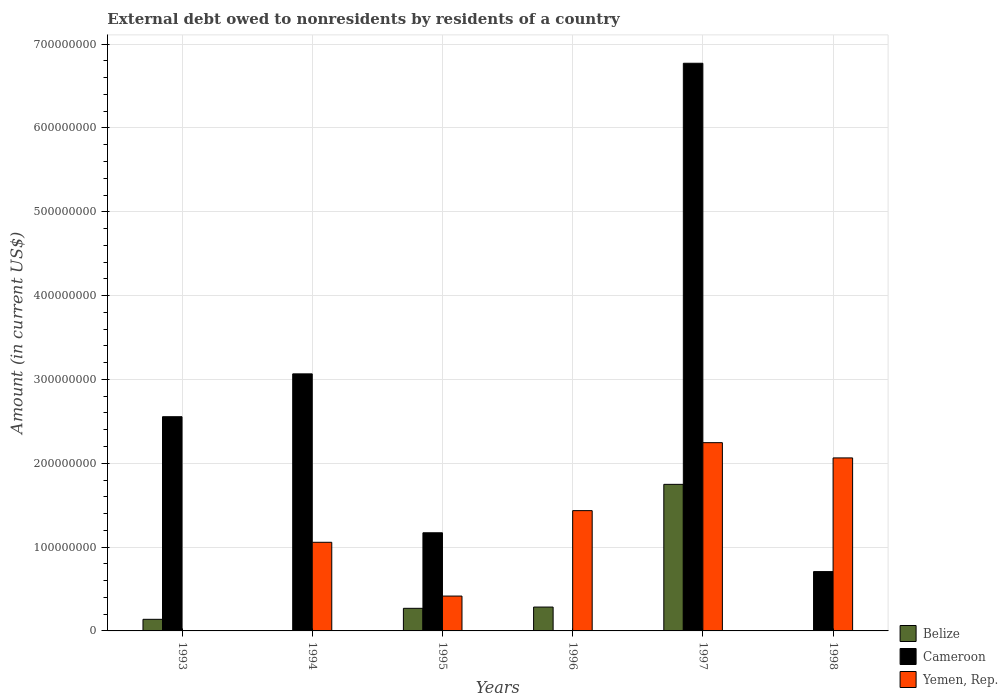How many different coloured bars are there?
Provide a short and direct response. 3. Are the number of bars on each tick of the X-axis equal?
Ensure brevity in your answer.  No. How many bars are there on the 4th tick from the right?
Ensure brevity in your answer.  3. In how many cases, is the number of bars for a given year not equal to the number of legend labels?
Provide a succinct answer. 4. What is the external debt owed by residents in Yemen, Rep. in 1997?
Make the answer very short. 2.25e+08. Across all years, what is the maximum external debt owed by residents in Yemen, Rep.?
Your response must be concise. 2.25e+08. In which year was the external debt owed by residents in Belize maximum?
Ensure brevity in your answer.  1997. What is the total external debt owed by residents in Yemen, Rep. in the graph?
Give a very brief answer. 7.22e+08. What is the difference between the external debt owed by residents in Cameroon in 1994 and that in 1998?
Provide a succinct answer. 2.36e+08. What is the difference between the external debt owed by residents in Belize in 1996 and the external debt owed by residents in Yemen, Rep. in 1994?
Your response must be concise. -7.73e+07. What is the average external debt owed by residents in Belize per year?
Keep it short and to the point. 4.07e+07. In the year 1995, what is the difference between the external debt owed by residents in Yemen, Rep. and external debt owed by residents in Cameroon?
Ensure brevity in your answer.  -7.55e+07. Is the external debt owed by residents in Belize in 1993 less than that in 1996?
Keep it short and to the point. Yes. Is the difference between the external debt owed by residents in Yemen, Rep. in 1994 and 1997 greater than the difference between the external debt owed by residents in Cameroon in 1994 and 1997?
Make the answer very short. Yes. What is the difference between the highest and the second highest external debt owed by residents in Yemen, Rep.?
Give a very brief answer. 1.82e+07. What is the difference between the highest and the lowest external debt owed by residents in Belize?
Provide a succinct answer. 1.75e+08. In how many years, is the external debt owed by residents in Yemen, Rep. greater than the average external debt owed by residents in Yemen, Rep. taken over all years?
Ensure brevity in your answer.  3. Is the sum of the external debt owed by residents in Cameroon in 1994 and 1998 greater than the maximum external debt owed by residents in Belize across all years?
Your response must be concise. Yes. Is it the case that in every year, the sum of the external debt owed by residents in Cameroon and external debt owed by residents in Belize is greater than the external debt owed by residents in Yemen, Rep.?
Provide a succinct answer. No. How many bars are there?
Provide a succinct answer. 14. What is the difference between two consecutive major ticks on the Y-axis?
Your response must be concise. 1.00e+08. Where does the legend appear in the graph?
Provide a succinct answer. Bottom right. What is the title of the graph?
Make the answer very short. External debt owed to nonresidents by residents of a country. Does "Lebanon" appear as one of the legend labels in the graph?
Ensure brevity in your answer.  No. What is the label or title of the Y-axis?
Ensure brevity in your answer.  Amount (in current US$). What is the Amount (in current US$) in Belize in 1993?
Give a very brief answer. 1.38e+07. What is the Amount (in current US$) in Cameroon in 1993?
Keep it short and to the point. 2.56e+08. What is the Amount (in current US$) in Yemen, Rep. in 1993?
Your answer should be very brief. 0. What is the Amount (in current US$) in Cameroon in 1994?
Provide a short and direct response. 3.07e+08. What is the Amount (in current US$) in Yemen, Rep. in 1994?
Keep it short and to the point. 1.06e+08. What is the Amount (in current US$) in Belize in 1995?
Provide a succinct answer. 2.70e+07. What is the Amount (in current US$) in Cameroon in 1995?
Your answer should be very brief. 1.17e+08. What is the Amount (in current US$) in Yemen, Rep. in 1995?
Your answer should be very brief. 4.16e+07. What is the Amount (in current US$) in Belize in 1996?
Offer a very short reply. 2.85e+07. What is the Amount (in current US$) in Cameroon in 1996?
Your answer should be compact. 0. What is the Amount (in current US$) in Yemen, Rep. in 1996?
Provide a short and direct response. 1.44e+08. What is the Amount (in current US$) of Belize in 1997?
Offer a very short reply. 1.75e+08. What is the Amount (in current US$) of Cameroon in 1997?
Your answer should be very brief. 6.77e+08. What is the Amount (in current US$) of Yemen, Rep. in 1997?
Provide a short and direct response. 2.25e+08. What is the Amount (in current US$) in Cameroon in 1998?
Your answer should be compact. 7.08e+07. What is the Amount (in current US$) in Yemen, Rep. in 1998?
Your response must be concise. 2.06e+08. Across all years, what is the maximum Amount (in current US$) of Belize?
Provide a short and direct response. 1.75e+08. Across all years, what is the maximum Amount (in current US$) in Cameroon?
Your response must be concise. 6.77e+08. Across all years, what is the maximum Amount (in current US$) of Yemen, Rep.?
Make the answer very short. 2.25e+08. Across all years, what is the minimum Amount (in current US$) in Cameroon?
Offer a very short reply. 0. Across all years, what is the minimum Amount (in current US$) in Yemen, Rep.?
Your answer should be compact. 0. What is the total Amount (in current US$) of Belize in the graph?
Your response must be concise. 2.44e+08. What is the total Amount (in current US$) in Cameroon in the graph?
Offer a terse response. 1.43e+09. What is the total Amount (in current US$) of Yemen, Rep. in the graph?
Offer a very short reply. 7.22e+08. What is the difference between the Amount (in current US$) in Cameroon in 1993 and that in 1994?
Offer a terse response. -5.11e+07. What is the difference between the Amount (in current US$) of Belize in 1993 and that in 1995?
Ensure brevity in your answer.  -1.31e+07. What is the difference between the Amount (in current US$) of Cameroon in 1993 and that in 1995?
Ensure brevity in your answer.  1.38e+08. What is the difference between the Amount (in current US$) in Belize in 1993 and that in 1996?
Provide a short and direct response. -1.46e+07. What is the difference between the Amount (in current US$) of Belize in 1993 and that in 1997?
Offer a terse response. -1.61e+08. What is the difference between the Amount (in current US$) in Cameroon in 1993 and that in 1997?
Your answer should be very brief. -4.22e+08. What is the difference between the Amount (in current US$) of Cameroon in 1993 and that in 1998?
Ensure brevity in your answer.  1.85e+08. What is the difference between the Amount (in current US$) in Cameroon in 1994 and that in 1995?
Your response must be concise. 1.90e+08. What is the difference between the Amount (in current US$) of Yemen, Rep. in 1994 and that in 1995?
Provide a succinct answer. 6.42e+07. What is the difference between the Amount (in current US$) in Yemen, Rep. in 1994 and that in 1996?
Give a very brief answer. -3.78e+07. What is the difference between the Amount (in current US$) of Cameroon in 1994 and that in 1997?
Your answer should be very brief. -3.71e+08. What is the difference between the Amount (in current US$) in Yemen, Rep. in 1994 and that in 1997?
Provide a succinct answer. -1.19e+08. What is the difference between the Amount (in current US$) in Cameroon in 1994 and that in 1998?
Your response must be concise. 2.36e+08. What is the difference between the Amount (in current US$) of Yemen, Rep. in 1994 and that in 1998?
Offer a very short reply. -1.01e+08. What is the difference between the Amount (in current US$) in Belize in 1995 and that in 1996?
Provide a short and direct response. -1.52e+06. What is the difference between the Amount (in current US$) in Yemen, Rep. in 1995 and that in 1996?
Provide a succinct answer. -1.02e+08. What is the difference between the Amount (in current US$) in Belize in 1995 and that in 1997?
Offer a very short reply. -1.48e+08. What is the difference between the Amount (in current US$) in Cameroon in 1995 and that in 1997?
Provide a succinct answer. -5.60e+08. What is the difference between the Amount (in current US$) of Yemen, Rep. in 1995 and that in 1997?
Your answer should be compact. -1.83e+08. What is the difference between the Amount (in current US$) of Cameroon in 1995 and that in 1998?
Offer a very short reply. 4.63e+07. What is the difference between the Amount (in current US$) in Yemen, Rep. in 1995 and that in 1998?
Your response must be concise. -1.65e+08. What is the difference between the Amount (in current US$) of Belize in 1996 and that in 1997?
Your answer should be compact. -1.46e+08. What is the difference between the Amount (in current US$) in Yemen, Rep. in 1996 and that in 1997?
Give a very brief answer. -8.11e+07. What is the difference between the Amount (in current US$) in Yemen, Rep. in 1996 and that in 1998?
Provide a succinct answer. -6.29e+07. What is the difference between the Amount (in current US$) in Cameroon in 1997 and that in 1998?
Offer a terse response. 6.06e+08. What is the difference between the Amount (in current US$) of Yemen, Rep. in 1997 and that in 1998?
Your answer should be compact. 1.82e+07. What is the difference between the Amount (in current US$) of Belize in 1993 and the Amount (in current US$) of Cameroon in 1994?
Your answer should be compact. -2.93e+08. What is the difference between the Amount (in current US$) in Belize in 1993 and the Amount (in current US$) in Yemen, Rep. in 1994?
Keep it short and to the point. -9.19e+07. What is the difference between the Amount (in current US$) in Cameroon in 1993 and the Amount (in current US$) in Yemen, Rep. in 1994?
Give a very brief answer. 1.50e+08. What is the difference between the Amount (in current US$) of Belize in 1993 and the Amount (in current US$) of Cameroon in 1995?
Offer a very short reply. -1.03e+08. What is the difference between the Amount (in current US$) in Belize in 1993 and the Amount (in current US$) in Yemen, Rep. in 1995?
Give a very brief answer. -2.77e+07. What is the difference between the Amount (in current US$) of Cameroon in 1993 and the Amount (in current US$) of Yemen, Rep. in 1995?
Make the answer very short. 2.14e+08. What is the difference between the Amount (in current US$) in Belize in 1993 and the Amount (in current US$) in Yemen, Rep. in 1996?
Ensure brevity in your answer.  -1.30e+08. What is the difference between the Amount (in current US$) of Cameroon in 1993 and the Amount (in current US$) of Yemen, Rep. in 1996?
Your answer should be very brief. 1.12e+08. What is the difference between the Amount (in current US$) of Belize in 1993 and the Amount (in current US$) of Cameroon in 1997?
Your answer should be very brief. -6.63e+08. What is the difference between the Amount (in current US$) in Belize in 1993 and the Amount (in current US$) in Yemen, Rep. in 1997?
Ensure brevity in your answer.  -2.11e+08. What is the difference between the Amount (in current US$) in Cameroon in 1993 and the Amount (in current US$) in Yemen, Rep. in 1997?
Your answer should be compact. 3.10e+07. What is the difference between the Amount (in current US$) of Belize in 1993 and the Amount (in current US$) of Cameroon in 1998?
Give a very brief answer. -5.69e+07. What is the difference between the Amount (in current US$) of Belize in 1993 and the Amount (in current US$) of Yemen, Rep. in 1998?
Offer a terse response. -1.93e+08. What is the difference between the Amount (in current US$) in Cameroon in 1993 and the Amount (in current US$) in Yemen, Rep. in 1998?
Give a very brief answer. 4.92e+07. What is the difference between the Amount (in current US$) in Cameroon in 1994 and the Amount (in current US$) in Yemen, Rep. in 1995?
Provide a short and direct response. 2.65e+08. What is the difference between the Amount (in current US$) in Cameroon in 1994 and the Amount (in current US$) in Yemen, Rep. in 1996?
Offer a terse response. 1.63e+08. What is the difference between the Amount (in current US$) in Cameroon in 1994 and the Amount (in current US$) in Yemen, Rep. in 1997?
Keep it short and to the point. 8.21e+07. What is the difference between the Amount (in current US$) of Cameroon in 1994 and the Amount (in current US$) of Yemen, Rep. in 1998?
Your answer should be compact. 1.00e+08. What is the difference between the Amount (in current US$) of Belize in 1995 and the Amount (in current US$) of Yemen, Rep. in 1996?
Your answer should be compact. -1.17e+08. What is the difference between the Amount (in current US$) in Cameroon in 1995 and the Amount (in current US$) in Yemen, Rep. in 1996?
Ensure brevity in your answer.  -2.64e+07. What is the difference between the Amount (in current US$) in Belize in 1995 and the Amount (in current US$) in Cameroon in 1997?
Keep it short and to the point. -6.50e+08. What is the difference between the Amount (in current US$) in Belize in 1995 and the Amount (in current US$) in Yemen, Rep. in 1997?
Offer a very short reply. -1.98e+08. What is the difference between the Amount (in current US$) in Cameroon in 1995 and the Amount (in current US$) in Yemen, Rep. in 1997?
Provide a succinct answer. -1.07e+08. What is the difference between the Amount (in current US$) in Belize in 1995 and the Amount (in current US$) in Cameroon in 1998?
Your answer should be very brief. -4.38e+07. What is the difference between the Amount (in current US$) of Belize in 1995 and the Amount (in current US$) of Yemen, Rep. in 1998?
Your answer should be very brief. -1.79e+08. What is the difference between the Amount (in current US$) of Cameroon in 1995 and the Amount (in current US$) of Yemen, Rep. in 1998?
Your response must be concise. -8.93e+07. What is the difference between the Amount (in current US$) of Belize in 1996 and the Amount (in current US$) of Cameroon in 1997?
Give a very brief answer. -6.49e+08. What is the difference between the Amount (in current US$) of Belize in 1996 and the Amount (in current US$) of Yemen, Rep. in 1997?
Your response must be concise. -1.96e+08. What is the difference between the Amount (in current US$) in Belize in 1996 and the Amount (in current US$) in Cameroon in 1998?
Your answer should be compact. -4.23e+07. What is the difference between the Amount (in current US$) of Belize in 1996 and the Amount (in current US$) of Yemen, Rep. in 1998?
Give a very brief answer. -1.78e+08. What is the difference between the Amount (in current US$) in Belize in 1997 and the Amount (in current US$) in Cameroon in 1998?
Offer a very short reply. 1.04e+08. What is the difference between the Amount (in current US$) of Belize in 1997 and the Amount (in current US$) of Yemen, Rep. in 1998?
Your answer should be compact. -3.15e+07. What is the difference between the Amount (in current US$) of Cameroon in 1997 and the Amount (in current US$) of Yemen, Rep. in 1998?
Keep it short and to the point. 4.71e+08. What is the average Amount (in current US$) in Belize per year?
Keep it short and to the point. 4.07e+07. What is the average Amount (in current US$) of Cameroon per year?
Your answer should be compact. 2.38e+08. What is the average Amount (in current US$) of Yemen, Rep. per year?
Ensure brevity in your answer.  1.20e+08. In the year 1993, what is the difference between the Amount (in current US$) of Belize and Amount (in current US$) of Cameroon?
Provide a succinct answer. -2.42e+08. In the year 1994, what is the difference between the Amount (in current US$) of Cameroon and Amount (in current US$) of Yemen, Rep.?
Offer a very short reply. 2.01e+08. In the year 1995, what is the difference between the Amount (in current US$) of Belize and Amount (in current US$) of Cameroon?
Your answer should be compact. -9.01e+07. In the year 1995, what is the difference between the Amount (in current US$) in Belize and Amount (in current US$) in Yemen, Rep.?
Provide a short and direct response. -1.46e+07. In the year 1995, what is the difference between the Amount (in current US$) of Cameroon and Amount (in current US$) of Yemen, Rep.?
Your answer should be compact. 7.55e+07. In the year 1996, what is the difference between the Amount (in current US$) of Belize and Amount (in current US$) of Yemen, Rep.?
Give a very brief answer. -1.15e+08. In the year 1997, what is the difference between the Amount (in current US$) of Belize and Amount (in current US$) of Cameroon?
Make the answer very short. -5.02e+08. In the year 1997, what is the difference between the Amount (in current US$) in Belize and Amount (in current US$) in Yemen, Rep.?
Provide a succinct answer. -4.97e+07. In the year 1997, what is the difference between the Amount (in current US$) in Cameroon and Amount (in current US$) in Yemen, Rep.?
Your answer should be very brief. 4.53e+08. In the year 1998, what is the difference between the Amount (in current US$) in Cameroon and Amount (in current US$) in Yemen, Rep.?
Ensure brevity in your answer.  -1.36e+08. What is the ratio of the Amount (in current US$) of Belize in 1993 to that in 1995?
Offer a very short reply. 0.51. What is the ratio of the Amount (in current US$) of Cameroon in 1993 to that in 1995?
Your response must be concise. 2.18. What is the ratio of the Amount (in current US$) of Belize in 1993 to that in 1996?
Your response must be concise. 0.49. What is the ratio of the Amount (in current US$) in Belize in 1993 to that in 1997?
Ensure brevity in your answer.  0.08. What is the ratio of the Amount (in current US$) in Cameroon in 1993 to that in 1997?
Your answer should be very brief. 0.38. What is the ratio of the Amount (in current US$) in Cameroon in 1993 to that in 1998?
Provide a succinct answer. 3.61. What is the ratio of the Amount (in current US$) of Cameroon in 1994 to that in 1995?
Offer a very short reply. 2.62. What is the ratio of the Amount (in current US$) in Yemen, Rep. in 1994 to that in 1995?
Make the answer very short. 2.54. What is the ratio of the Amount (in current US$) in Yemen, Rep. in 1994 to that in 1996?
Your response must be concise. 0.74. What is the ratio of the Amount (in current US$) in Cameroon in 1994 to that in 1997?
Ensure brevity in your answer.  0.45. What is the ratio of the Amount (in current US$) of Yemen, Rep. in 1994 to that in 1997?
Offer a very short reply. 0.47. What is the ratio of the Amount (in current US$) in Cameroon in 1994 to that in 1998?
Provide a succinct answer. 4.33. What is the ratio of the Amount (in current US$) in Yemen, Rep. in 1994 to that in 1998?
Your response must be concise. 0.51. What is the ratio of the Amount (in current US$) of Belize in 1995 to that in 1996?
Ensure brevity in your answer.  0.95. What is the ratio of the Amount (in current US$) of Yemen, Rep. in 1995 to that in 1996?
Offer a terse response. 0.29. What is the ratio of the Amount (in current US$) in Belize in 1995 to that in 1997?
Offer a terse response. 0.15. What is the ratio of the Amount (in current US$) of Cameroon in 1995 to that in 1997?
Ensure brevity in your answer.  0.17. What is the ratio of the Amount (in current US$) in Yemen, Rep. in 1995 to that in 1997?
Make the answer very short. 0.19. What is the ratio of the Amount (in current US$) in Cameroon in 1995 to that in 1998?
Keep it short and to the point. 1.65. What is the ratio of the Amount (in current US$) in Yemen, Rep. in 1995 to that in 1998?
Your response must be concise. 0.2. What is the ratio of the Amount (in current US$) of Belize in 1996 to that in 1997?
Your answer should be compact. 0.16. What is the ratio of the Amount (in current US$) of Yemen, Rep. in 1996 to that in 1997?
Your answer should be very brief. 0.64. What is the ratio of the Amount (in current US$) in Yemen, Rep. in 1996 to that in 1998?
Ensure brevity in your answer.  0.7. What is the ratio of the Amount (in current US$) in Cameroon in 1997 to that in 1998?
Offer a very short reply. 9.57. What is the ratio of the Amount (in current US$) of Yemen, Rep. in 1997 to that in 1998?
Provide a succinct answer. 1.09. What is the difference between the highest and the second highest Amount (in current US$) in Belize?
Provide a succinct answer. 1.46e+08. What is the difference between the highest and the second highest Amount (in current US$) in Cameroon?
Provide a succinct answer. 3.71e+08. What is the difference between the highest and the second highest Amount (in current US$) of Yemen, Rep.?
Keep it short and to the point. 1.82e+07. What is the difference between the highest and the lowest Amount (in current US$) in Belize?
Provide a short and direct response. 1.75e+08. What is the difference between the highest and the lowest Amount (in current US$) of Cameroon?
Make the answer very short. 6.77e+08. What is the difference between the highest and the lowest Amount (in current US$) in Yemen, Rep.?
Offer a terse response. 2.25e+08. 